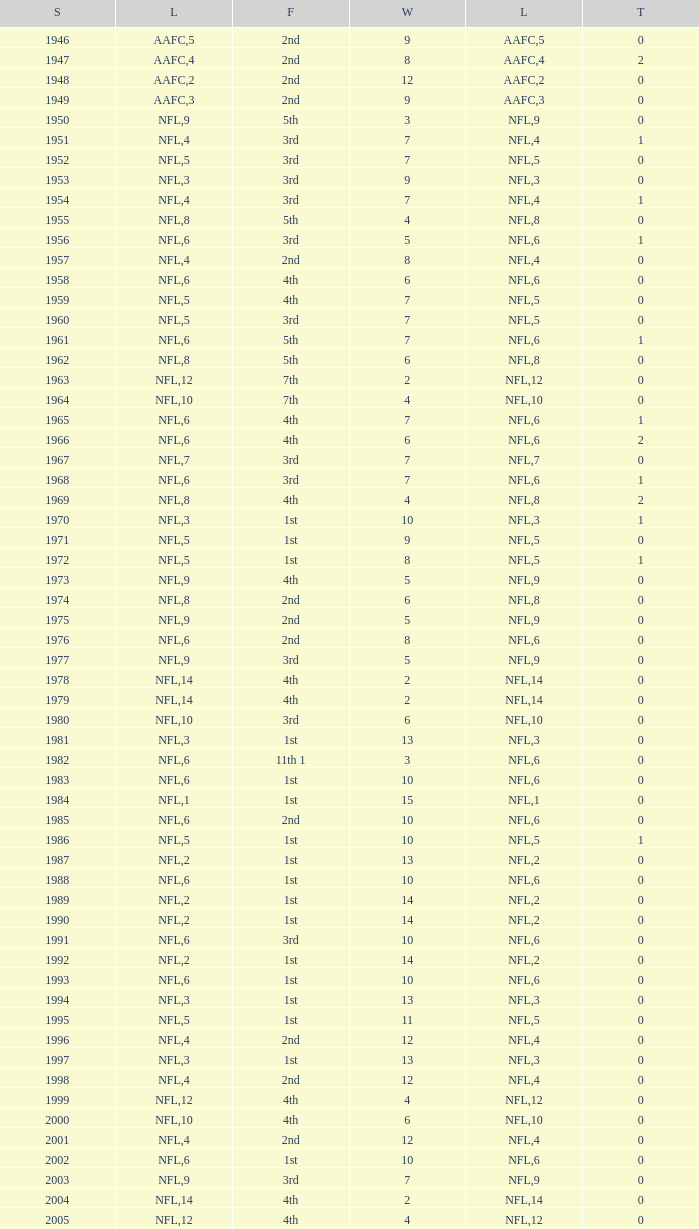What is the lowest number of ties in the NFL, with less than 2 losses and less than 15 wins? None. 